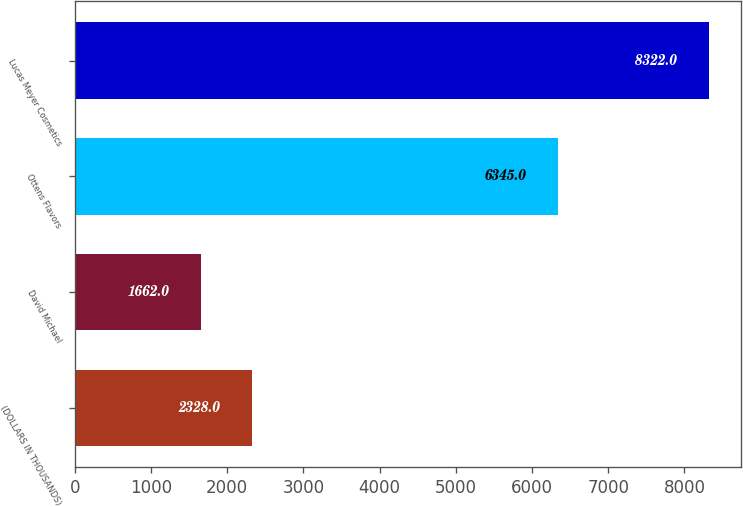Convert chart to OTSL. <chart><loc_0><loc_0><loc_500><loc_500><bar_chart><fcel>(DOLLARS IN THOUSANDS)<fcel>David Michael<fcel>Ottens Flavors<fcel>Lucas Meyer Cosmetics<nl><fcel>2328<fcel>1662<fcel>6345<fcel>8322<nl></chart> 